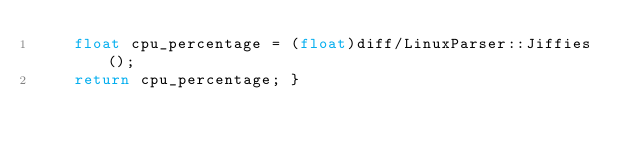<code> <loc_0><loc_0><loc_500><loc_500><_C++_>    float cpu_percentage = (float)diff/LinuxParser::Jiffies();
    return cpu_percentage; }</code> 